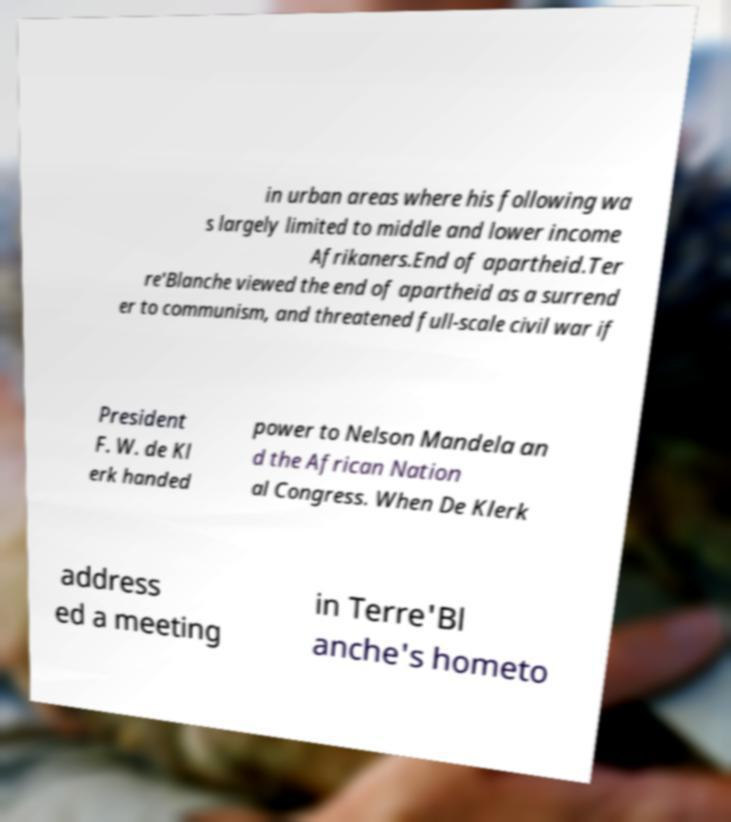For documentation purposes, I need the text within this image transcribed. Could you provide that? in urban areas where his following wa s largely limited to middle and lower income Afrikaners.End of apartheid.Ter re'Blanche viewed the end of apartheid as a surrend er to communism, and threatened full-scale civil war if President F. W. de Kl erk handed power to Nelson Mandela an d the African Nation al Congress. When De Klerk address ed a meeting in Terre'Bl anche's hometo 